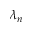Convert formula to latex. <formula><loc_0><loc_0><loc_500><loc_500>\lambda _ { n }</formula> 